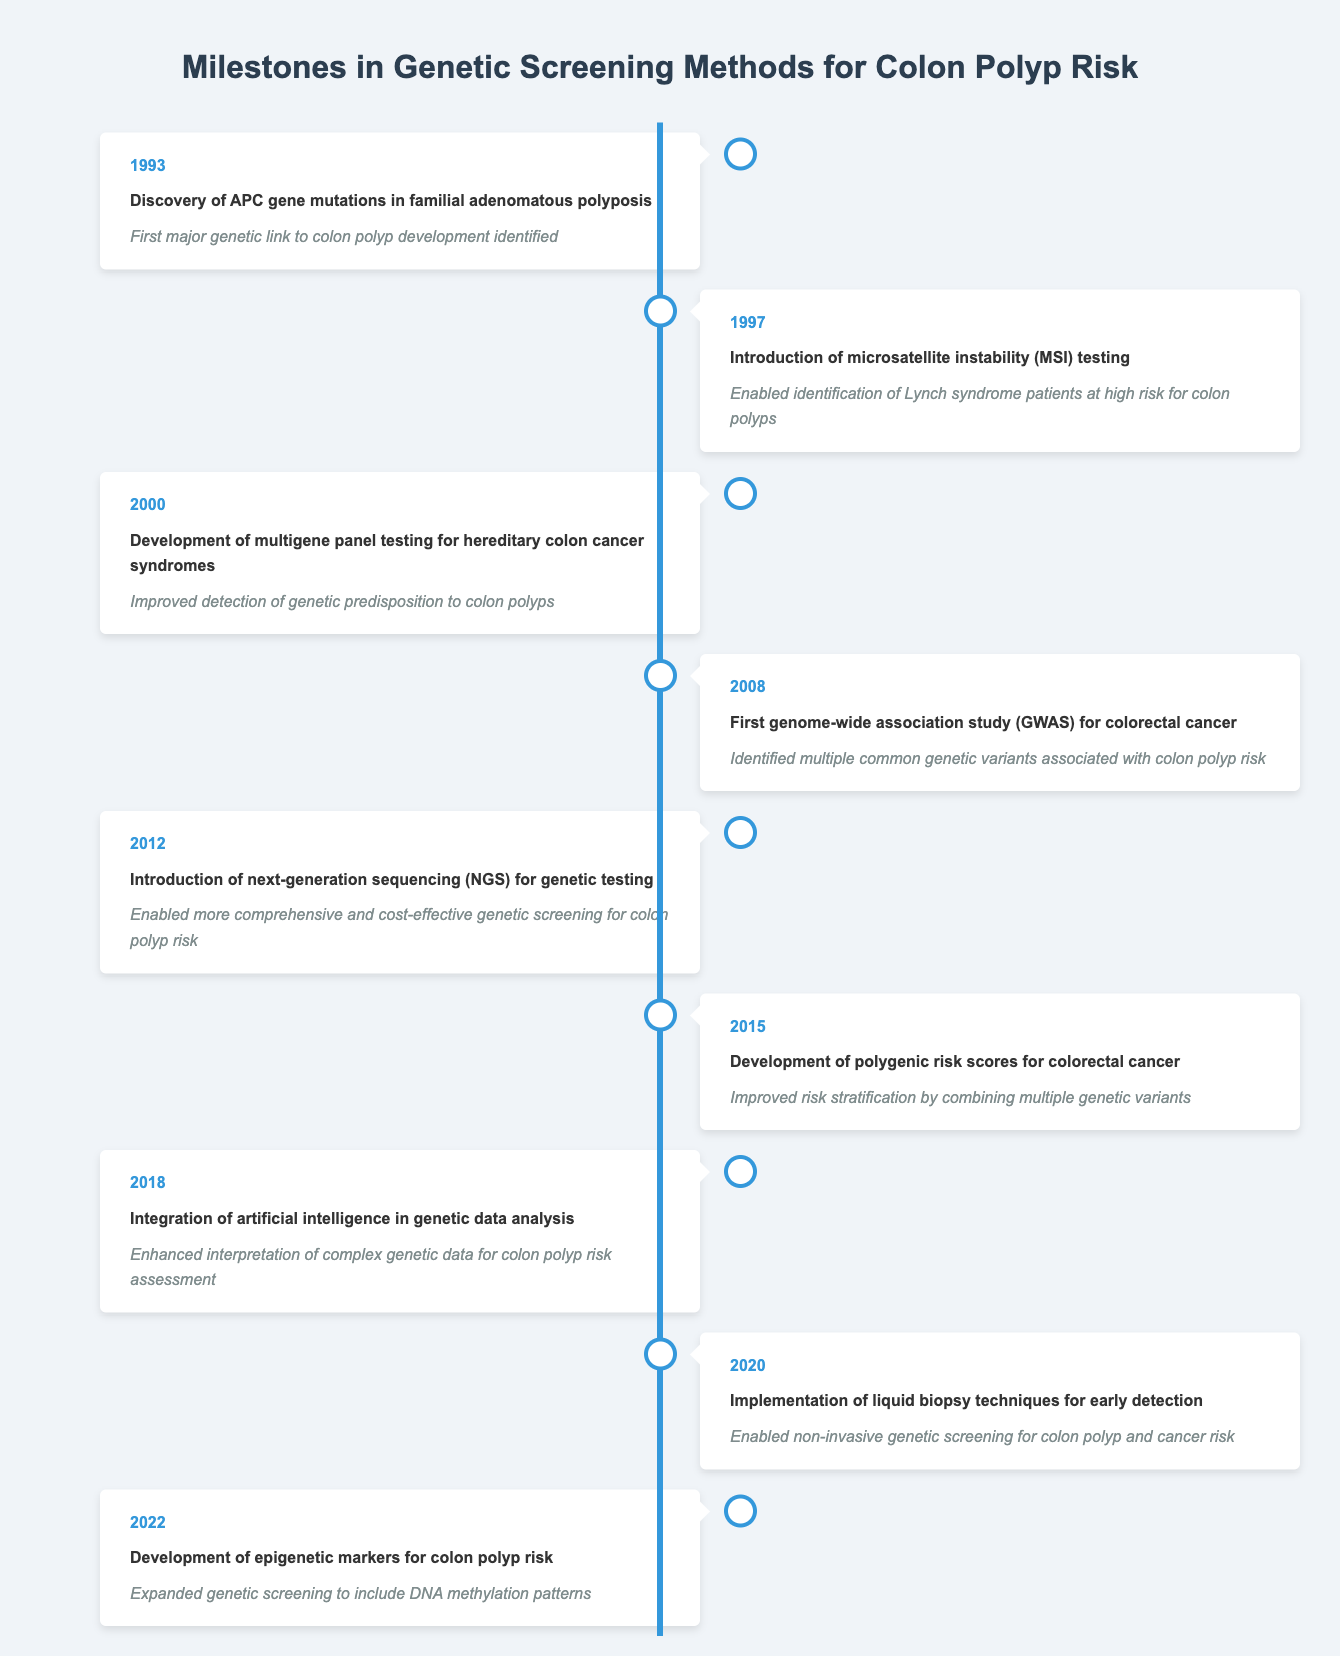What year was the APC gene mutation discovered? The APC gene mutations linked to familial adenomatous polyposis were discovered in 1993, as indicated in the timeline.
Answer: 1993 What are the specific advancements in genetic testing introduced in 2012? The introduction of next-generation sequencing for genetic testing in 2012 allowed for more comprehensive and cost-effective genetic screening for colon polyp risk.
Answer: Next-generation sequencing How many years apart are the discovery of APC gene mutations and the introduction of liquid biopsy techniques? The discovery of APC gene mutations occurred in 1993 and the introduction of liquid biopsy techniques was in 2020. The difference is 2020 - 1993 = 27 years.
Answer: 27 years Did the year 2015 see any advancements in risk stratification for colorectal cancer? Yes, the development of polygenic risk scores for colorectal cancer occurred in 2015, which improved risk stratification by combining multiple genetic variants.
Answer: Yes What was the significance of the genome-wide association study conducted in 2008? The 2008 genome-wide association study identified multiple common genetic variants associated with colon polyp risk, marking an important advancement in understanding genetic factors.
Answer: Identified multiple common genetic variants What events in the timeline contributed to improved genetic screening methods for colon polyp risk? The major events include the discovery of APC gene mutations in 1993, introduction of MSI testing in 1997, development of multigene panel testing in 2000, and the introduction of next-generation sequencing in 2012, all of which enhanced genetic screening methods.
Answer: Discovery of APC gene mutations, MSI testing, multigene panel testing, next-generation sequencing Which milestone provided a non-invasive method for genetic screening for colon polyp and cancer risk? The implementation of liquid biopsy techniques in 2020 provided a non-invasive method for genetic screening for colon polyp and cancer risk.
Answer: Liquid biopsy techniques What type of advancements were introduced between 2000 and 2015 in genetic screening for colon polyp risk? Between 2000 and 2015, multigene panel testing in 2000, genome-wide association study in 2008, and development of polygenic risk scores in 2015 contributed advancements in genetic screening methods for colon polyp risk.
Answer: Multigene panel testing, genome-wide association study, polygenic risk scores In what way did the introduction of artificial intelligence in 2018 enhance genetic data analysis related to colon polyp risk? The integration of artificial intelligence in 2018 enhanced interpretation of complex genetic data, facilitating better risk assessment for colon polyp development.
Answer: Enhanced interpretation of complex genetic data 